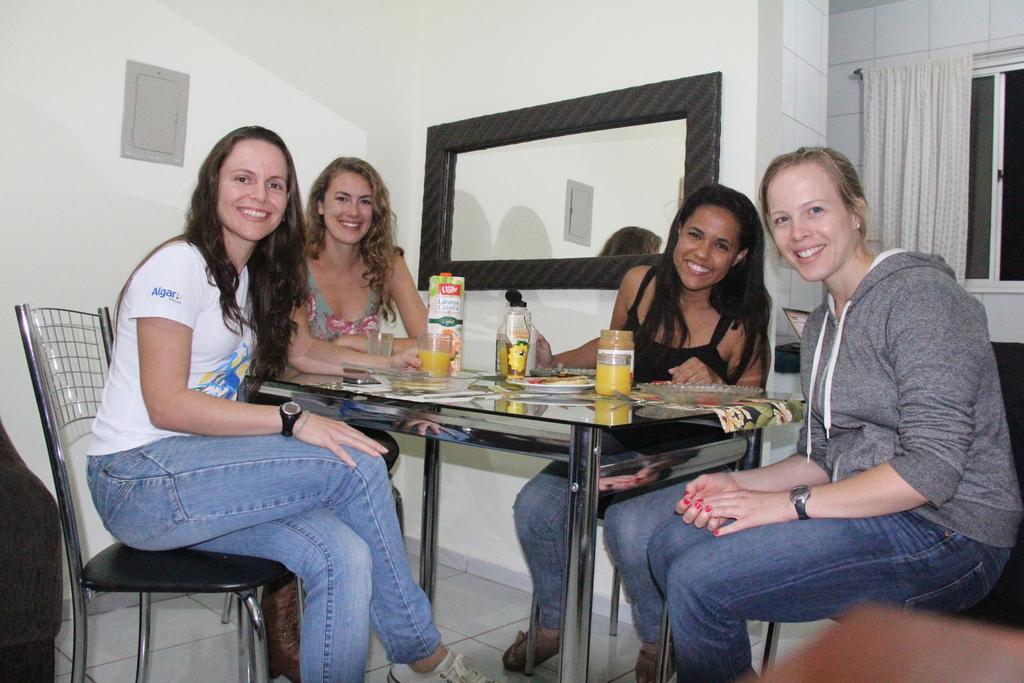Please provide a concise description of this image. In this image, there are four women's sitting on the chair in front of the table on which glass, jar, plates and squeeze bottle is kept. The background walls are white in color. In the middle a mirror is visible. And on the right, a curtain is visible of white in color and window is visible. This image is taken inside a room. 